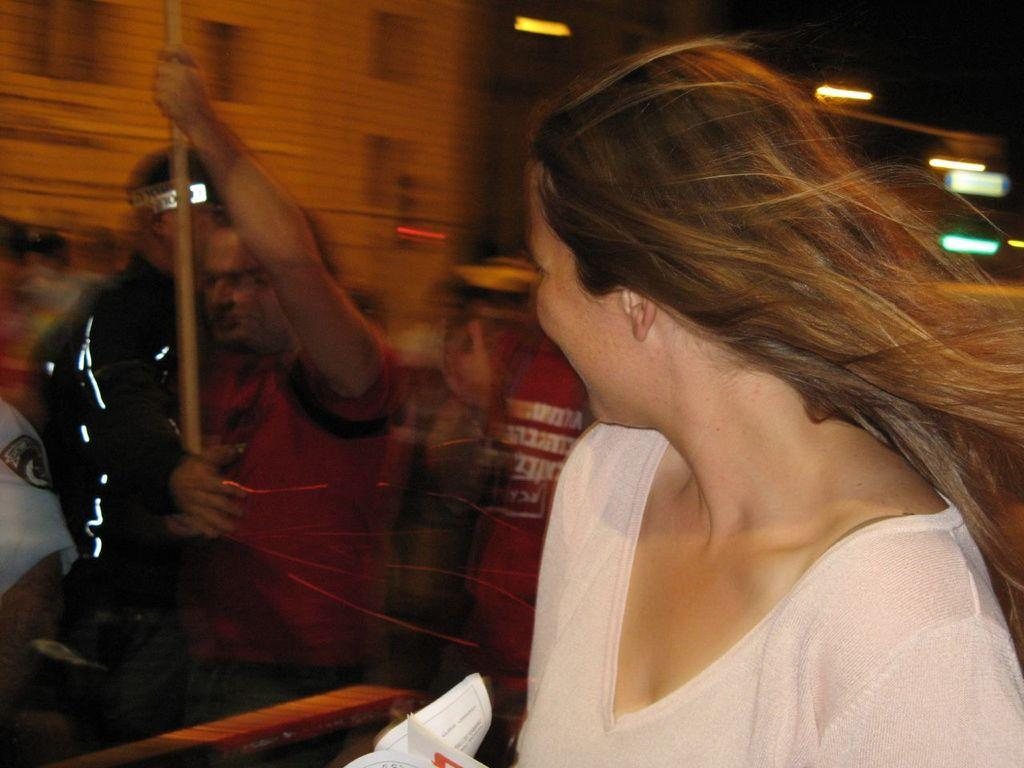Who or what is the main subject of the image? There is a person in the image. Can you describe the surroundings of the person? In the background of the image, there is a group of people and a building. What type of canvas is the person painting on in the image? There is no canvas or painting activity present in the image. 